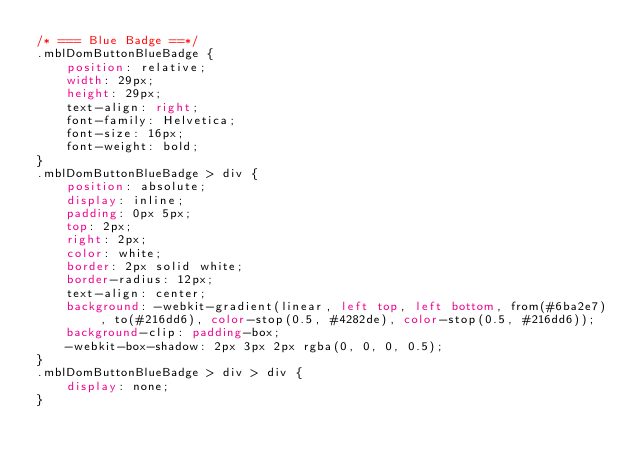Convert code to text. <code><loc_0><loc_0><loc_500><loc_500><_CSS_>/* === Blue Badge ==*/
.mblDomButtonBlueBadge {
	position: relative;
	width: 29px;
	height: 29px;
	text-align: right;
	font-family: Helvetica;
	font-size: 16px;
	font-weight: bold;
}
.mblDomButtonBlueBadge > div {
	position: absolute;
	display: inline;
	padding: 0px 5px;
	top: 2px;
	right: 2px;
	color: white;
	border: 2px solid white;
	border-radius: 12px;
	text-align: center;
	background: -webkit-gradient(linear, left top, left bottom, from(#6ba2e7), to(#216dd6), color-stop(0.5, #4282de), color-stop(0.5, #216dd6));
	background-clip: padding-box;
	-webkit-box-shadow: 2px 3px 2px rgba(0, 0, 0, 0.5);
}
.mblDomButtonBlueBadge > div > div {
	display: none;
}
</code> 